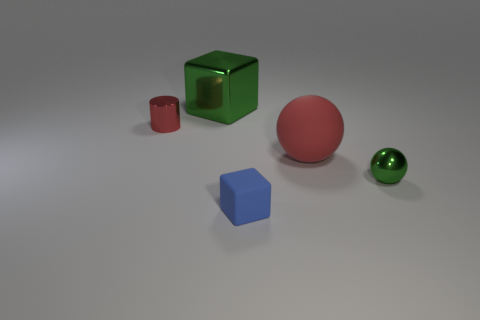How big is the green block?
Make the answer very short. Large. Are there fewer red objects that are in front of the small metallic cylinder than red matte balls?
Provide a succinct answer. No. Does the blue object have the same size as the red metal thing?
Your answer should be compact. Yes. Is there any other thing that has the same size as the matte sphere?
Your response must be concise. Yes. What is the color of the small thing that is the same material as the small red cylinder?
Offer a very short reply. Green. Are there fewer tiny green metallic things that are on the left side of the large red rubber ball than cylinders that are on the left side of the tiny red metal cylinder?
Provide a succinct answer. No. How many small balls have the same color as the shiny block?
Keep it short and to the point. 1. What is the material of the thing that is the same color as the big ball?
Give a very brief answer. Metal. How many small things are on the left side of the large sphere and on the right side of the big metal thing?
Your answer should be compact. 1. There is a green object right of the large thing that is in front of the big green shiny thing; what is it made of?
Provide a short and direct response. Metal. 